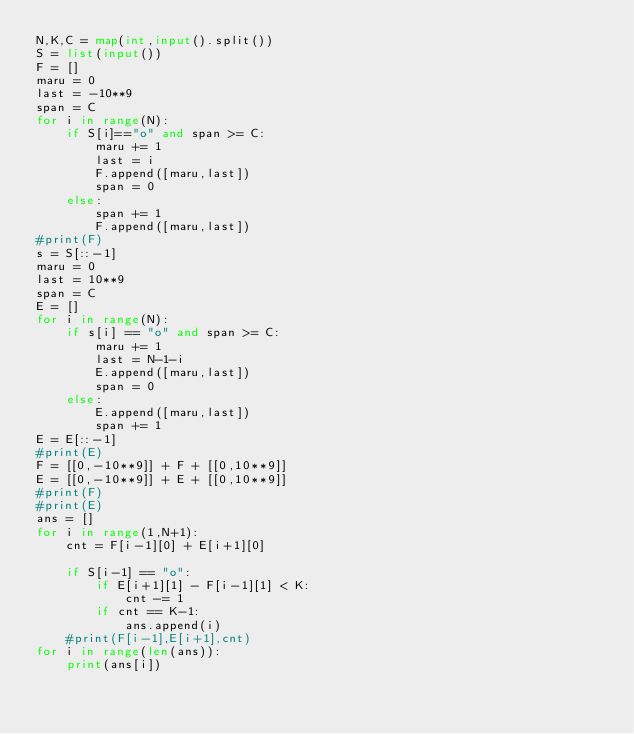Convert code to text. <code><loc_0><loc_0><loc_500><loc_500><_Python_>N,K,C = map(int,input().split())
S = list(input())
F = []
maru = 0
last = -10**9
span = C
for i in range(N):
    if S[i]=="o" and span >= C:
        maru += 1
        last = i
        F.append([maru,last])
        span = 0
    else:
        span += 1
        F.append([maru,last])
#print(F)
s = S[::-1]
maru = 0
last = 10**9
span = C
E = []
for i in range(N):
    if s[i] == "o" and span >= C:
        maru += 1
        last = N-1-i
        E.append([maru,last])
        span = 0
    else:
        E.append([maru,last])
        span += 1
E = E[::-1]
#print(E)
F = [[0,-10**9]] + F + [[0,10**9]]
E = [[0,-10**9]] + E + [[0,10**9]]
#print(F)
#print(E)
ans = []
for i in range(1,N+1):
    cnt = F[i-1][0] + E[i+1][0]
    
    if S[i-1] == "o":
        if E[i+1][1] - F[i-1][1] < K:
            cnt -= 1
        if cnt == K-1:
            ans.append(i)
    #print(F[i-1],E[i+1],cnt)
for i in range(len(ans)):
    print(ans[i])</code> 